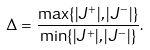<formula> <loc_0><loc_0><loc_500><loc_500>\Delta = \frac { \max \{ | J ^ { + } | , | J ^ { - } | \} } { \min \{ | J ^ { + } | , | J ^ { - } | \} } .</formula> 